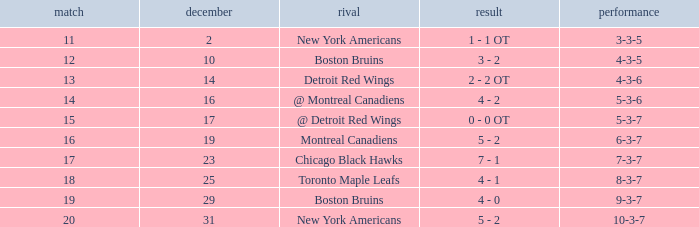Which Score has a December smaller than 14, and a Game of 12? 3 - 2. 